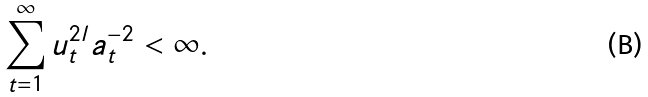<formula> <loc_0><loc_0><loc_500><loc_500>\sum _ { t = 1 } ^ { \infty } u _ { t } ^ { 2 l } a _ { t } ^ { - 2 } < \infty .</formula> 